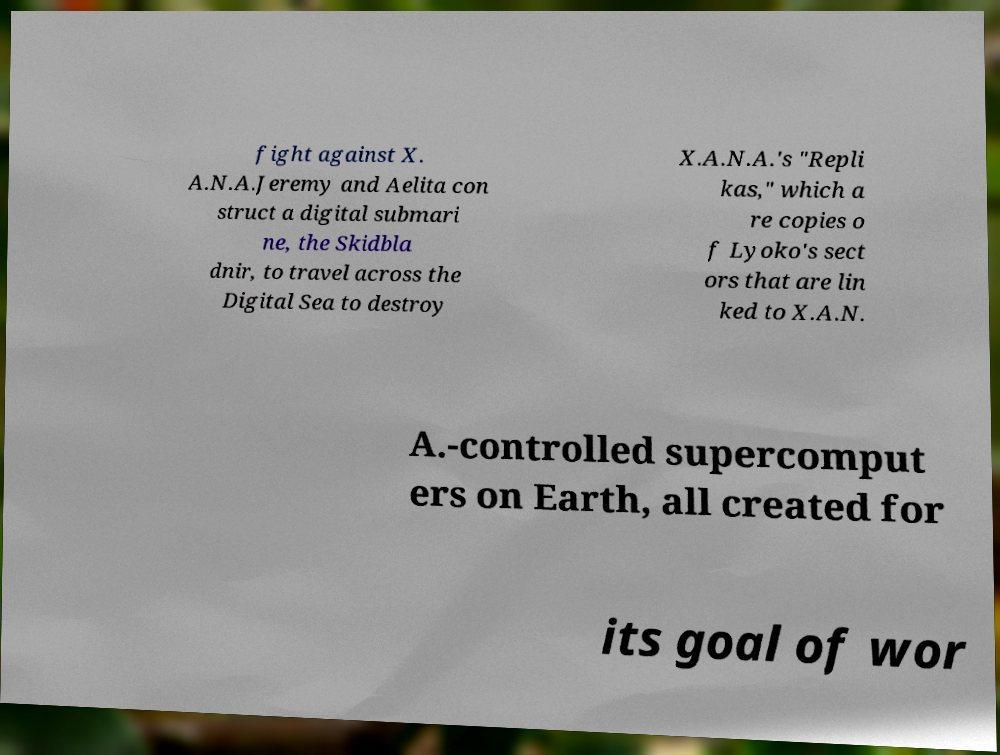Could you assist in decoding the text presented in this image and type it out clearly? fight against X. A.N.A.Jeremy and Aelita con struct a digital submari ne, the Skidbla dnir, to travel across the Digital Sea to destroy X.A.N.A.'s "Repli kas," which a re copies o f Lyoko's sect ors that are lin ked to X.A.N. A.-controlled supercomput ers on Earth, all created for its goal of wor 